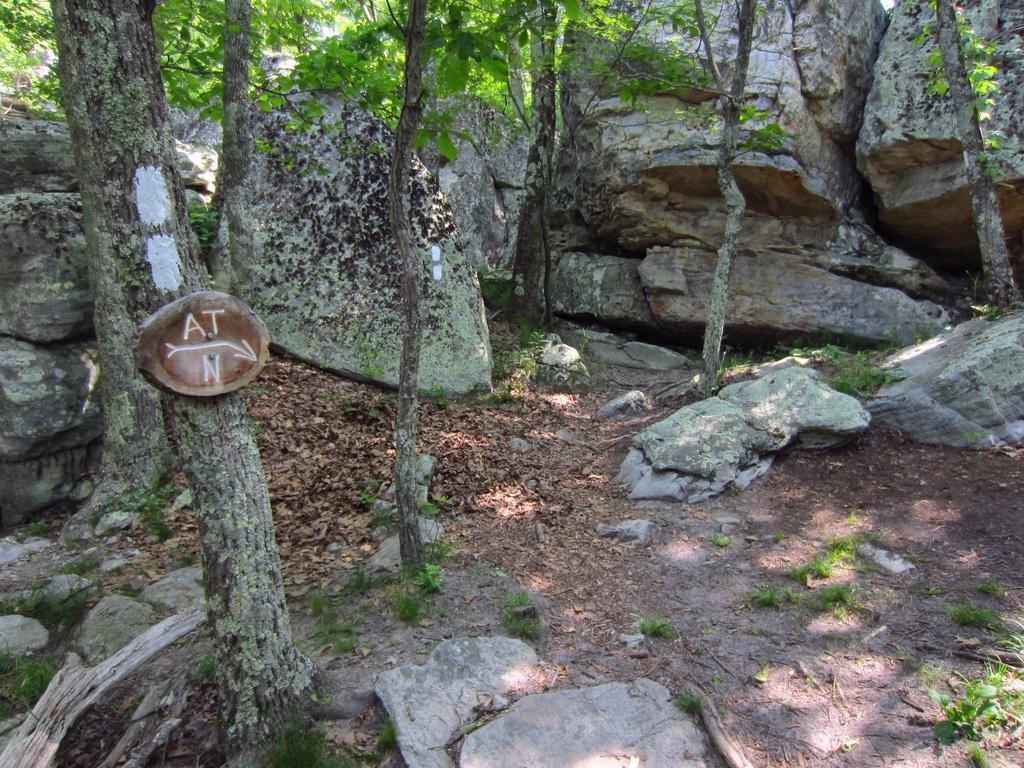Please provide a concise description of this image. In this image we can see there are some trees, rocks and dry leaves on the ground. 